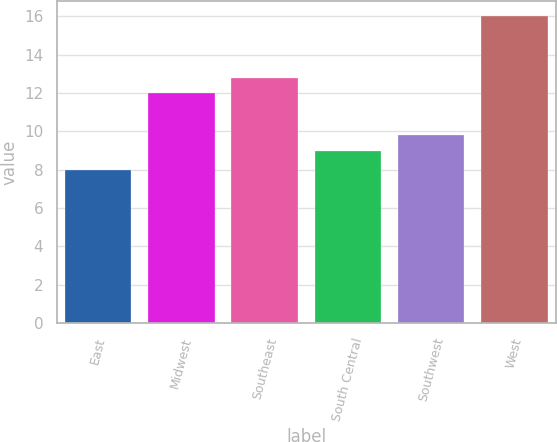Convert chart. <chart><loc_0><loc_0><loc_500><loc_500><bar_chart><fcel>East<fcel>Midwest<fcel>Southeast<fcel>South Central<fcel>Southwest<fcel>West<nl><fcel>8<fcel>12<fcel>12.8<fcel>9<fcel>9.8<fcel>16<nl></chart> 